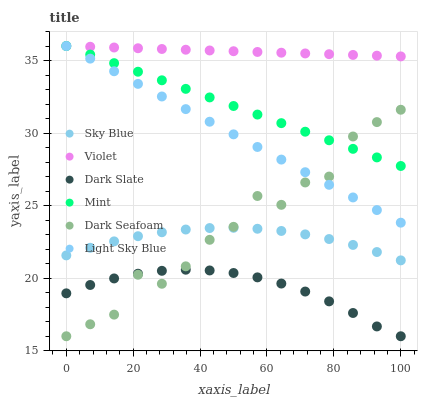Does Dark Slate have the minimum area under the curve?
Answer yes or no. Yes. Does Violet have the maximum area under the curve?
Answer yes or no. Yes. Does Dark Seafoam have the minimum area under the curve?
Answer yes or no. No. Does Dark Seafoam have the maximum area under the curve?
Answer yes or no. No. Is Mint the smoothest?
Answer yes or no. Yes. Is Dark Seafoam the roughest?
Answer yes or no. Yes. Is Light Sky Blue the smoothest?
Answer yes or no. No. Is Light Sky Blue the roughest?
Answer yes or no. No. Does Dark Slate have the lowest value?
Answer yes or no. Yes. Does Light Sky Blue have the lowest value?
Answer yes or no. No. Does Mint have the highest value?
Answer yes or no. Yes. Does Dark Seafoam have the highest value?
Answer yes or no. No. Is Dark Seafoam less than Violet?
Answer yes or no. Yes. Is Mint greater than Sky Blue?
Answer yes or no. Yes. Does Light Sky Blue intersect Mint?
Answer yes or no. Yes. Is Light Sky Blue less than Mint?
Answer yes or no. No. Is Light Sky Blue greater than Mint?
Answer yes or no. No. Does Dark Seafoam intersect Violet?
Answer yes or no. No. 